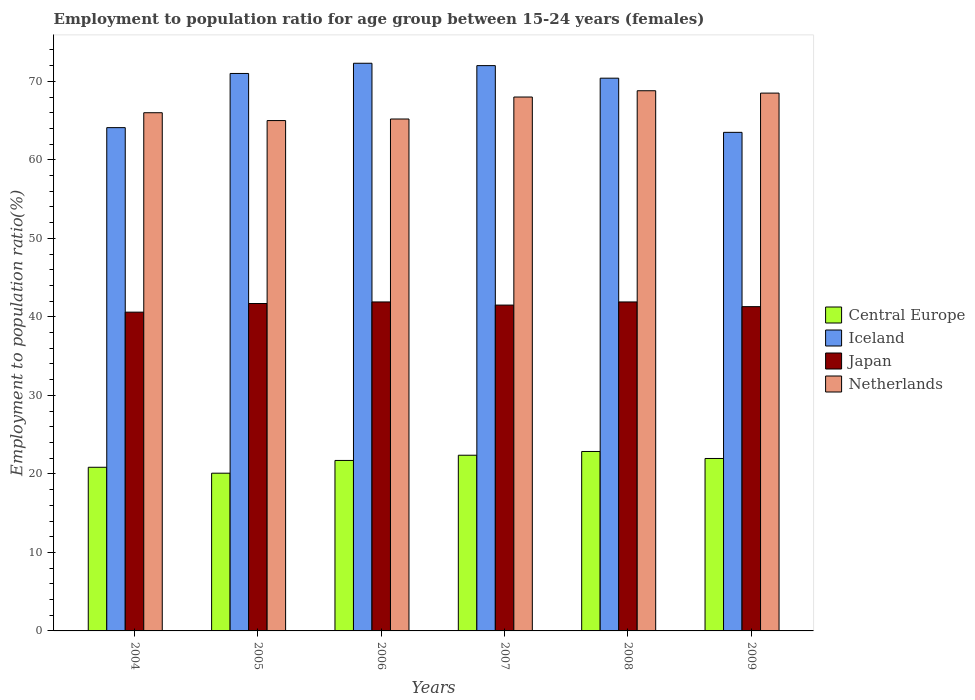How many bars are there on the 3rd tick from the right?
Your answer should be compact. 4. What is the label of the 6th group of bars from the left?
Your answer should be very brief. 2009. What is the employment to population ratio in Japan in 2008?
Offer a terse response. 41.9. Across all years, what is the maximum employment to population ratio in Iceland?
Ensure brevity in your answer.  72.3. Across all years, what is the minimum employment to population ratio in Japan?
Make the answer very short. 40.6. In which year was the employment to population ratio in Central Europe minimum?
Your response must be concise. 2005. What is the total employment to population ratio in Iceland in the graph?
Your answer should be very brief. 413.3. What is the difference between the employment to population ratio in Netherlands in 2007 and the employment to population ratio in Iceland in 2006?
Your answer should be very brief. -4.3. What is the average employment to population ratio in Japan per year?
Your response must be concise. 41.48. In the year 2009, what is the difference between the employment to population ratio in Japan and employment to population ratio in Iceland?
Your response must be concise. -22.2. In how many years, is the employment to population ratio in Iceland greater than 52 %?
Provide a short and direct response. 6. What is the ratio of the employment to population ratio in Iceland in 2006 to that in 2008?
Offer a very short reply. 1.03. Is the difference between the employment to population ratio in Japan in 2004 and 2009 greater than the difference between the employment to population ratio in Iceland in 2004 and 2009?
Offer a very short reply. No. What is the difference between the highest and the second highest employment to population ratio in Netherlands?
Your answer should be compact. 0.3. What is the difference between the highest and the lowest employment to population ratio in Netherlands?
Keep it short and to the point. 3.8. Is the sum of the employment to population ratio in Central Europe in 2007 and 2009 greater than the maximum employment to population ratio in Iceland across all years?
Provide a short and direct response. No. What does the 4th bar from the left in 2006 represents?
Make the answer very short. Netherlands. What does the 4th bar from the right in 2007 represents?
Make the answer very short. Central Europe. How many bars are there?
Make the answer very short. 24. Are all the bars in the graph horizontal?
Make the answer very short. No. How many years are there in the graph?
Keep it short and to the point. 6. What is the difference between two consecutive major ticks on the Y-axis?
Make the answer very short. 10. Are the values on the major ticks of Y-axis written in scientific E-notation?
Give a very brief answer. No. Does the graph contain any zero values?
Offer a very short reply. No. Does the graph contain grids?
Offer a terse response. No. Where does the legend appear in the graph?
Your answer should be compact. Center right. How many legend labels are there?
Offer a very short reply. 4. What is the title of the graph?
Your answer should be compact. Employment to population ratio for age group between 15-24 years (females). What is the label or title of the X-axis?
Give a very brief answer. Years. What is the label or title of the Y-axis?
Your answer should be compact. Employment to population ratio(%). What is the Employment to population ratio(%) of Central Europe in 2004?
Your answer should be very brief. 20.84. What is the Employment to population ratio(%) in Iceland in 2004?
Provide a succinct answer. 64.1. What is the Employment to population ratio(%) of Japan in 2004?
Your answer should be very brief. 40.6. What is the Employment to population ratio(%) of Central Europe in 2005?
Offer a terse response. 20.09. What is the Employment to population ratio(%) in Iceland in 2005?
Offer a very short reply. 71. What is the Employment to population ratio(%) in Japan in 2005?
Provide a succinct answer. 41.7. What is the Employment to population ratio(%) of Central Europe in 2006?
Give a very brief answer. 21.71. What is the Employment to population ratio(%) in Iceland in 2006?
Give a very brief answer. 72.3. What is the Employment to population ratio(%) in Japan in 2006?
Your answer should be very brief. 41.9. What is the Employment to population ratio(%) of Netherlands in 2006?
Offer a very short reply. 65.2. What is the Employment to population ratio(%) of Central Europe in 2007?
Provide a succinct answer. 22.38. What is the Employment to population ratio(%) of Japan in 2007?
Make the answer very short. 41.5. What is the Employment to population ratio(%) of Netherlands in 2007?
Ensure brevity in your answer.  68. What is the Employment to population ratio(%) in Central Europe in 2008?
Offer a terse response. 22.86. What is the Employment to population ratio(%) in Iceland in 2008?
Your answer should be very brief. 70.4. What is the Employment to population ratio(%) in Japan in 2008?
Provide a succinct answer. 41.9. What is the Employment to population ratio(%) of Netherlands in 2008?
Your answer should be compact. 68.8. What is the Employment to population ratio(%) of Central Europe in 2009?
Offer a terse response. 21.96. What is the Employment to population ratio(%) in Iceland in 2009?
Keep it short and to the point. 63.5. What is the Employment to population ratio(%) of Japan in 2009?
Ensure brevity in your answer.  41.3. What is the Employment to population ratio(%) in Netherlands in 2009?
Provide a short and direct response. 68.5. Across all years, what is the maximum Employment to population ratio(%) in Central Europe?
Your response must be concise. 22.86. Across all years, what is the maximum Employment to population ratio(%) in Iceland?
Your answer should be compact. 72.3. Across all years, what is the maximum Employment to population ratio(%) of Japan?
Your response must be concise. 41.9. Across all years, what is the maximum Employment to population ratio(%) of Netherlands?
Your response must be concise. 68.8. Across all years, what is the minimum Employment to population ratio(%) of Central Europe?
Give a very brief answer. 20.09. Across all years, what is the minimum Employment to population ratio(%) in Iceland?
Ensure brevity in your answer.  63.5. Across all years, what is the minimum Employment to population ratio(%) of Japan?
Your response must be concise. 40.6. What is the total Employment to population ratio(%) in Central Europe in the graph?
Offer a very short reply. 129.84. What is the total Employment to population ratio(%) of Iceland in the graph?
Provide a succinct answer. 413.3. What is the total Employment to population ratio(%) in Japan in the graph?
Ensure brevity in your answer.  248.9. What is the total Employment to population ratio(%) of Netherlands in the graph?
Your answer should be very brief. 401.5. What is the difference between the Employment to population ratio(%) in Central Europe in 2004 and that in 2005?
Keep it short and to the point. 0.76. What is the difference between the Employment to population ratio(%) of Netherlands in 2004 and that in 2005?
Provide a succinct answer. 1. What is the difference between the Employment to population ratio(%) of Central Europe in 2004 and that in 2006?
Ensure brevity in your answer.  -0.87. What is the difference between the Employment to population ratio(%) of Iceland in 2004 and that in 2006?
Ensure brevity in your answer.  -8.2. What is the difference between the Employment to population ratio(%) in Japan in 2004 and that in 2006?
Offer a very short reply. -1.3. What is the difference between the Employment to population ratio(%) of Central Europe in 2004 and that in 2007?
Ensure brevity in your answer.  -1.53. What is the difference between the Employment to population ratio(%) of Japan in 2004 and that in 2007?
Keep it short and to the point. -0.9. What is the difference between the Employment to population ratio(%) in Netherlands in 2004 and that in 2007?
Offer a terse response. -2. What is the difference between the Employment to population ratio(%) of Central Europe in 2004 and that in 2008?
Your response must be concise. -2.01. What is the difference between the Employment to population ratio(%) in Central Europe in 2004 and that in 2009?
Your answer should be very brief. -1.12. What is the difference between the Employment to population ratio(%) in Iceland in 2004 and that in 2009?
Provide a succinct answer. 0.6. What is the difference between the Employment to population ratio(%) in Japan in 2004 and that in 2009?
Offer a very short reply. -0.7. What is the difference between the Employment to population ratio(%) in Central Europe in 2005 and that in 2006?
Make the answer very short. -1.62. What is the difference between the Employment to population ratio(%) in Iceland in 2005 and that in 2006?
Your answer should be compact. -1.3. What is the difference between the Employment to population ratio(%) of Japan in 2005 and that in 2006?
Make the answer very short. -0.2. What is the difference between the Employment to population ratio(%) of Netherlands in 2005 and that in 2006?
Your response must be concise. -0.2. What is the difference between the Employment to population ratio(%) of Central Europe in 2005 and that in 2007?
Your response must be concise. -2.29. What is the difference between the Employment to population ratio(%) in Iceland in 2005 and that in 2007?
Provide a succinct answer. -1. What is the difference between the Employment to population ratio(%) of Japan in 2005 and that in 2007?
Keep it short and to the point. 0.2. What is the difference between the Employment to population ratio(%) in Central Europe in 2005 and that in 2008?
Offer a terse response. -2.77. What is the difference between the Employment to population ratio(%) of Iceland in 2005 and that in 2008?
Keep it short and to the point. 0.6. What is the difference between the Employment to population ratio(%) of Central Europe in 2005 and that in 2009?
Your answer should be very brief. -1.87. What is the difference between the Employment to population ratio(%) in Iceland in 2005 and that in 2009?
Provide a short and direct response. 7.5. What is the difference between the Employment to population ratio(%) in Japan in 2005 and that in 2009?
Your answer should be compact. 0.4. What is the difference between the Employment to population ratio(%) of Central Europe in 2006 and that in 2007?
Provide a short and direct response. -0.66. What is the difference between the Employment to population ratio(%) in Central Europe in 2006 and that in 2008?
Offer a very short reply. -1.14. What is the difference between the Employment to population ratio(%) in Netherlands in 2006 and that in 2008?
Give a very brief answer. -3.6. What is the difference between the Employment to population ratio(%) of Central Europe in 2006 and that in 2009?
Make the answer very short. -0.25. What is the difference between the Employment to population ratio(%) of Iceland in 2006 and that in 2009?
Give a very brief answer. 8.8. What is the difference between the Employment to population ratio(%) of Japan in 2006 and that in 2009?
Provide a succinct answer. 0.6. What is the difference between the Employment to population ratio(%) in Central Europe in 2007 and that in 2008?
Provide a short and direct response. -0.48. What is the difference between the Employment to population ratio(%) in Iceland in 2007 and that in 2008?
Ensure brevity in your answer.  1.6. What is the difference between the Employment to population ratio(%) of Japan in 2007 and that in 2008?
Your answer should be compact. -0.4. What is the difference between the Employment to population ratio(%) of Netherlands in 2007 and that in 2008?
Keep it short and to the point. -0.8. What is the difference between the Employment to population ratio(%) in Central Europe in 2007 and that in 2009?
Your response must be concise. 0.41. What is the difference between the Employment to population ratio(%) in Iceland in 2007 and that in 2009?
Ensure brevity in your answer.  8.5. What is the difference between the Employment to population ratio(%) of Japan in 2007 and that in 2009?
Provide a succinct answer. 0.2. What is the difference between the Employment to population ratio(%) in Netherlands in 2007 and that in 2009?
Provide a succinct answer. -0.5. What is the difference between the Employment to population ratio(%) of Central Europe in 2008 and that in 2009?
Give a very brief answer. 0.89. What is the difference between the Employment to population ratio(%) in Iceland in 2008 and that in 2009?
Offer a very short reply. 6.9. What is the difference between the Employment to population ratio(%) in Japan in 2008 and that in 2009?
Provide a succinct answer. 0.6. What is the difference between the Employment to population ratio(%) in Central Europe in 2004 and the Employment to population ratio(%) in Iceland in 2005?
Provide a succinct answer. -50.16. What is the difference between the Employment to population ratio(%) in Central Europe in 2004 and the Employment to population ratio(%) in Japan in 2005?
Make the answer very short. -20.86. What is the difference between the Employment to population ratio(%) of Central Europe in 2004 and the Employment to population ratio(%) of Netherlands in 2005?
Provide a succinct answer. -44.16. What is the difference between the Employment to population ratio(%) in Iceland in 2004 and the Employment to population ratio(%) in Japan in 2005?
Make the answer very short. 22.4. What is the difference between the Employment to population ratio(%) of Japan in 2004 and the Employment to population ratio(%) of Netherlands in 2005?
Give a very brief answer. -24.4. What is the difference between the Employment to population ratio(%) in Central Europe in 2004 and the Employment to population ratio(%) in Iceland in 2006?
Offer a terse response. -51.46. What is the difference between the Employment to population ratio(%) in Central Europe in 2004 and the Employment to population ratio(%) in Japan in 2006?
Ensure brevity in your answer.  -21.06. What is the difference between the Employment to population ratio(%) in Central Europe in 2004 and the Employment to population ratio(%) in Netherlands in 2006?
Your answer should be very brief. -44.36. What is the difference between the Employment to population ratio(%) of Iceland in 2004 and the Employment to population ratio(%) of Japan in 2006?
Make the answer very short. 22.2. What is the difference between the Employment to population ratio(%) of Iceland in 2004 and the Employment to population ratio(%) of Netherlands in 2006?
Give a very brief answer. -1.1. What is the difference between the Employment to population ratio(%) in Japan in 2004 and the Employment to population ratio(%) in Netherlands in 2006?
Offer a terse response. -24.6. What is the difference between the Employment to population ratio(%) of Central Europe in 2004 and the Employment to population ratio(%) of Iceland in 2007?
Ensure brevity in your answer.  -51.16. What is the difference between the Employment to population ratio(%) of Central Europe in 2004 and the Employment to population ratio(%) of Japan in 2007?
Provide a succinct answer. -20.66. What is the difference between the Employment to population ratio(%) of Central Europe in 2004 and the Employment to population ratio(%) of Netherlands in 2007?
Offer a terse response. -47.16. What is the difference between the Employment to population ratio(%) of Iceland in 2004 and the Employment to population ratio(%) of Japan in 2007?
Make the answer very short. 22.6. What is the difference between the Employment to population ratio(%) of Japan in 2004 and the Employment to population ratio(%) of Netherlands in 2007?
Ensure brevity in your answer.  -27.4. What is the difference between the Employment to population ratio(%) of Central Europe in 2004 and the Employment to population ratio(%) of Iceland in 2008?
Provide a short and direct response. -49.56. What is the difference between the Employment to population ratio(%) in Central Europe in 2004 and the Employment to population ratio(%) in Japan in 2008?
Ensure brevity in your answer.  -21.06. What is the difference between the Employment to population ratio(%) in Central Europe in 2004 and the Employment to population ratio(%) in Netherlands in 2008?
Keep it short and to the point. -47.96. What is the difference between the Employment to population ratio(%) in Iceland in 2004 and the Employment to population ratio(%) in Netherlands in 2008?
Your answer should be compact. -4.7. What is the difference between the Employment to population ratio(%) in Japan in 2004 and the Employment to population ratio(%) in Netherlands in 2008?
Offer a terse response. -28.2. What is the difference between the Employment to population ratio(%) of Central Europe in 2004 and the Employment to population ratio(%) of Iceland in 2009?
Provide a succinct answer. -42.66. What is the difference between the Employment to population ratio(%) of Central Europe in 2004 and the Employment to population ratio(%) of Japan in 2009?
Make the answer very short. -20.46. What is the difference between the Employment to population ratio(%) of Central Europe in 2004 and the Employment to population ratio(%) of Netherlands in 2009?
Give a very brief answer. -47.66. What is the difference between the Employment to population ratio(%) in Iceland in 2004 and the Employment to population ratio(%) in Japan in 2009?
Provide a short and direct response. 22.8. What is the difference between the Employment to population ratio(%) in Iceland in 2004 and the Employment to population ratio(%) in Netherlands in 2009?
Offer a very short reply. -4.4. What is the difference between the Employment to population ratio(%) in Japan in 2004 and the Employment to population ratio(%) in Netherlands in 2009?
Give a very brief answer. -27.9. What is the difference between the Employment to population ratio(%) in Central Europe in 2005 and the Employment to population ratio(%) in Iceland in 2006?
Your answer should be compact. -52.21. What is the difference between the Employment to population ratio(%) of Central Europe in 2005 and the Employment to population ratio(%) of Japan in 2006?
Your answer should be compact. -21.81. What is the difference between the Employment to population ratio(%) of Central Europe in 2005 and the Employment to population ratio(%) of Netherlands in 2006?
Your answer should be very brief. -45.11. What is the difference between the Employment to population ratio(%) in Iceland in 2005 and the Employment to population ratio(%) in Japan in 2006?
Your answer should be compact. 29.1. What is the difference between the Employment to population ratio(%) in Japan in 2005 and the Employment to population ratio(%) in Netherlands in 2006?
Offer a terse response. -23.5. What is the difference between the Employment to population ratio(%) of Central Europe in 2005 and the Employment to population ratio(%) of Iceland in 2007?
Give a very brief answer. -51.91. What is the difference between the Employment to population ratio(%) of Central Europe in 2005 and the Employment to population ratio(%) of Japan in 2007?
Your answer should be compact. -21.41. What is the difference between the Employment to population ratio(%) in Central Europe in 2005 and the Employment to population ratio(%) in Netherlands in 2007?
Your answer should be very brief. -47.91. What is the difference between the Employment to population ratio(%) of Iceland in 2005 and the Employment to population ratio(%) of Japan in 2007?
Your response must be concise. 29.5. What is the difference between the Employment to population ratio(%) in Japan in 2005 and the Employment to population ratio(%) in Netherlands in 2007?
Your response must be concise. -26.3. What is the difference between the Employment to population ratio(%) in Central Europe in 2005 and the Employment to population ratio(%) in Iceland in 2008?
Your answer should be compact. -50.31. What is the difference between the Employment to population ratio(%) of Central Europe in 2005 and the Employment to population ratio(%) of Japan in 2008?
Offer a terse response. -21.81. What is the difference between the Employment to population ratio(%) in Central Europe in 2005 and the Employment to population ratio(%) in Netherlands in 2008?
Ensure brevity in your answer.  -48.71. What is the difference between the Employment to population ratio(%) in Iceland in 2005 and the Employment to population ratio(%) in Japan in 2008?
Make the answer very short. 29.1. What is the difference between the Employment to population ratio(%) in Iceland in 2005 and the Employment to population ratio(%) in Netherlands in 2008?
Provide a short and direct response. 2.2. What is the difference between the Employment to population ratio(%) in Japan in 2005 and the Employment to population ratio(%) in Netherlands in 2008?
Your response must be concise. -27.1. What is the difference between the Employment to population ratio(%) of Central Europe in 2005 and the Employment to population ratio(%) of Iceland in 2009?
Provide a short and direct response. -43.41. What is the difference between the Employment to population ratio(%) in Central Europe in 2005 and the Employment to population ratio(%) in Japan in 2009?
Provide a succinct answer. -21.21. What is the difference between the Employment to population ratio(%) in Central Europe in 2005 and the Employment to population ratio(%) in Netherlands in 2009?
Your answer should be very brief. -48.41. What is the difference between the Employment to population ratio(%) in Iceland in 2005 and the Employment to population ratio(%) in Japan in 2009?
Make the answer very short. 29.7. What is the difference between the Employment to population ratio(%) of Iceland in 2005 and the Employment to population ratio(%) of Netherlands in 2009?
Make the answer very short. 2.5. What is the difference between the Employment to population ratio(%) of Japan in 2005 and the Employment to population ratio(%) of Netherlands in 2009?
Make the answer very short. -26.8. What is the difference between the Employment to population ratio(%) in Central Europe in 2006 and the Employment to population ratio(%) in Iceland in 2007?
Offer a terse response. -50.29. What is the difference between the Employment to population ratio(%) of Central Europe in 2006 and the Employment to population ratio(%) of Japan in 2007?
Your answer should be compact. -19.79. What is the difference between the Employment to population ratio(%) of Central Europe in 2006 and the Employment to population ratio(%) of Netherlands in 2007?
Give a very brief answer. -46.29. What is the difference between the Employment to population ratio(%) of Iceland in 2006 and the Employment to population ratio(%) of Japan in 2007?
Your answer should be very brief. 30.8. What is the difference between the Employment to population ratio(%) of Japan in 2006 and the Employment to population ratio(%) of Netherlands in 2007?
Offer a very short reply. -26.1. What is the difference between the Employment to population ratio(%) in Central Europe in 2006 and the Employment to population ratio(%) in Iceland in 2008?
Make the answer very short. -48.69. What is the difference between the Employment to population ratio(%) in Central Europe in 2006 and the Employment to population ratio(%) in Japan in 2008?
Keep it short and to the point. -20.19. What is the difference between the Employment to population ratio(%) in Central Europe in 2006 and the Employment to population ratio(%) in Netherlands in 2008?
Ensure brevity in your answer.  -47.09. What is the difference between the Employment to population ratio(%) in Iceland in 2006 and the Employment to population ratio(%) in Japan in 2008?
Your answer should be very brief. 30.4. What is the difference between the Employment to population ratio(%) in Iceland in 2006 and the Employment to population ratio(%) in Netherlands in 2008?
Offer a terse response. 3.5. What is the difference between the Employment to population ratio(%) in Japan in 2006 and the Employment to population ratio(%) in Netherlands in 2008?
Make the answer very short. -26.9. What is the difference between the Employment to population ratio(%) in Central Europe in 2006 and the Employment to population ratio(%) in Iceland in 2009?
Give a very brief answer. -41.79. What is the difference between the Employment to population ratio(%) of Central Europe in 2006 and the Employment to population ratio(%) of Japan in 2009?
Provide a succinct answer. -19.59. What is the difference between the Employment to population ratio(%) in Central Europe in 2006 and the Employment to population ratio(%) in Netherlands in 2009?
Give a very brief answer. -46.79. What is the difference between the Employment to population ratio(%) in Iceland in 2006 and the Employment to population ratio(%) in Japan in 2009?
Your answer should be very brief. 31. What is the difference between the Employment to population ratio(%) of Japan in 2006 and the Employment to population ratio(%) of Netherlands in 2009?
Ensure brevity in your answer.  -26.6. What is the difference between the Employment to population ratio(%) of Central Europe in 2007 and the Employment to population ratio(%) of Iceland in 2008?
Offer a very short reply. -48.02. What is the difference between the Employment to population ratio(%) in Central Europe in 2007 and the Employment to population ratio(%) in Japan in 2008?
Offer a terse response. -19.52. What is the difference between the Employment to population ratio(%) of Central Europe in 2007 and the Employment to population ratio(%) of Netherlands in 2008?
Offer a terse response. -46.42. What is the difference between the Employment to population ratio(%) in Iceland in 2007 and the Employment to population ratio(%) in Japan in 2008?
Offer a terse response. 30.1. What is the difference between the Employment to population ratio(%) of Japan in 2007 and the Employment to population ratio(%) of Netherlands in 2008?
Your answer should be compact. -27.3. What is the difference between the Employment to population ratio(%) of Central Europe in 2007 and the Employment to population ratio(%) of Iceland in 2009?
Make the answer very short. -41.12. What is the difference between the Employment to population ratio(%) of Central Europe in 2007 and the Employment to population ratio(%) of Japan in 2009?
Provide a succinct answer. -18.92. What is the difference between the Employment to population ratio(%) in Central Europe in 2007 and the Employment to population ratio(%) in Netherlands in 2009?
Your answer should be compact. -46.12. What is the difference between the Employment to population ratio(%) of Iceland in 2007 and the Employment to population ratio(%) of Japan in 2009?
Keep it short and to the point. 30.7. What is the difference between the Employment to population ratio(%) in Iceland in 2007 and the Employment to population ratio(%) in Netherlands in 2009?
Provide a short and direct response. 3.5. What is the difference between the Employment to population ratio(%) in Central Europe in 2008 and the Employment to population ratio(%) in Iceland in 2009?
Give a very brief answer. -40.64. What is the difference between the Employment to population ratio(%) of Central Europe in 2008 and the Employment to population ratio(%) of Japan in 2009?
Keep it short and to the point. -18.44. What is the difference between the Employment to population ratio(%) of Central Europe in 2008 and the Employment to population ratio(%) of Netherlands in 2009?
Your answer should be compact. -45.64. What is the difference between the Employment to population ratio(%) in Iceland in 2008 and the Employment to population ratio(%) in Japan in 2009?
Give a very brief answer. 29.1. What is the difference between the Employment to population ratio(%) in Iceland in 2008 and the Employment to population ratio(%) in Netherlands in 2009?
Keep it short and to the point. 1.9. What is the difference between the Employment to population ratio(%) in Japan in 2008 and the Employment to population ratio(%) in Netherlands in 2009?
Provide a short and direct response. -26.6. What is the average Employment to population ratio(%) in Central Europe per year?
Make the answer very short. 21.64. What is the average Employment to population ratio(%) of Iceland per year?
Your answer should be compact. 68.88. What is the average Employment to population ratio(%) of Japan per year?
Ensure brevity in your answer.  41.48. What is the average Employment to population ratio(%) of Netherlands per year?
Ensure brevity in your answer.  66.92. In the year 2004, what is the difference between the Employment to population ratio(%) in Central Europe and Employment to population ratio(%) in Iceland?
Your answer should be compact. -43.26. In the year 2004, what is the difference between the Employment to population ratio(%) in Central Europe and Employment to population ratio(%) in Japan?
Make the answer very short. -19.76. In the year 2004, what is the difference between the Employment to population ratio(%) of Central Europe and Employment to population ratio(%) of Netherlands?
Provide a succinct answer. -45.16. In the year 2004, what is the difference between the Employment to population ratio(%) of Iceland and Employment to population ratio(%) of Japan?
Give a very brief answer. 23.5. In the year 2004, what is the difference between the Employment to population ratio(%) of Iceland and Employment to population ratio(%) of Netherlands?
Your answer should be compact. -1.9. In the year 2004, what is the difference between the Employment to population ratio(%) in Japan and Employment to population ratio(%) in Netherlands?
Provide a short and direct response. -25.4. In the year 2005, what is the difference between the Employment to population ratio(%) in Central Europe and Employment to population ratio(%) in Iceland?
Offer a very short reply. -50.91. In the year 2005, what is the difference between the Employment to population ratio(%) of Central Europe and Employment to population ratio(%) of Japan?
Provide a short and direct response. -21.61. In the year 2005, what is the difference between the Employment to population ratio(%) in Central Europe and Employment to population ratio(%) in Netherlands?
Provide a short and direct response. -44.91. In the year 2005, what is the difference between the Employment to population ratio(%) in Iceland and Employment to population ratio(%) in Japan?
Your answer should be very brief. 29.3. In the year 2005, what is the difference between the Employment to population ratio(%) of Japan and Employment to population ratio(%) of Netherlands?
Keep it short and to the point. -23.3. In the year 2006, what is the difference between the Employment to population ratio(%) in Central Europe and Employment to population ratio(%) in Iceland?
Offer a terse response. -50.59. In the year 2006, what is the difference between the Employment to population ratio(%) of Central Europe and Employment to population ratio(%) of Japan?
Offer a terse response. -20.19. In the year 2006, what is the difference between the Employment to population ratio(%) of Central Europe and Employment to population ratio(%) of Netherlands?
Provide a succinct answer. -43.49. In the year 2006, what is the difference between the Employment to population ratio(%) of Iceland and Employment to population ratio(%) of Japan?
Your response must be concise. 30.4. In the year 2006, what is the difference between the Employment to population ratio(%) of Japan and Employment to population ratio(%) of Netherlands?
Make the answer very short. -23.3. In the year 2007, what is the difference between the Employment to population ratio(%) of Central Europe and Employment to population ratio(%) of Iceland?
Ensure brevity in your answer.  -49.62. In the year 2007, what is the difference between the Employment to population ratio(%) in Central Europe and Employment to population ratio(%) in Japan?
Make the answer very short. -19.12. In the year 2007, what is the difference between the Employment to population ratio(%) of Central Europe and Employment to population ratio(%) of Netherlands?
Provide a short and direct response. -45.62. In the year 2007, what is the difference between the Employment to population ratio(%) in Iceland and Employment to population ratio(%) in Japan?
Provide a short and direct response. 30.5. In the year 2007, what is the difference between the Employment to population ratio(%) in Iceland and Employment to population ratio(%) in Netherlands?
Offer a very short reply. 4. In the year 2007, what is the difference between the Employment to population ratio(%) in Japan and Employment to population ratio(%) in Netherlands?
Your response must be concise. -26.5. In the year 2008, what is the difference between the Employment to population ratio(%) in Central Europe and Employment to population ratio(%) in Iceland?
Offer a very short reply. -47.54. In the year 2008, what is the difference between the Employment to population ratio(%) of Central Europe and Employment to population ratio(%) of Japan?
Provide a succinct answer. -19.04. In the year 2008, what is the difference between the Employment to population ratio(%) in Central Europe and Employment to population ratio(%) in Netherlands?
Offer a very short reply. -45.94. In the year 2008, what is the difference between the Employment to population ratio(%) of Iceland and Employment to population ratio(%) of Japan?
Make the answer very short. 28.5. In the year 2008, what is the difference between the Employment to population ratio(%) of Japan and Employment to population ratio(%) of Netherlands?
Your answer should be very brief. -26.9. In the year 2009, what is the difference between the Employment to population ratio(%) of Central Europe and Employment to population ratio(%) of Iceland?
Provide a succinct answer. -41.54. In the year 2009, what is the difference between the Employment to population ratio(%) in Central Europe and Employment to population ratio(%) in Japan?
Provide a short and direct response. -19.34. In the year 2009, what is the difference between the Employment to population ratio(%) in Central Europe and Employment to population ratio(%) in Netherlands?
Your answer should be compact. -46.54. In the year 2009, what is the difference between the Employment to population ratio(%) of Iceland and Employment to population ratio(%) of Japan?
Your answer should be very brief. 22.2. In the year 2009, what is the difference between the Employment to population ratio(%) of Japan and Employment to population ratio(%) of Netherlands?
Your answer should be compact. -27.2. What is the ratio of the Employment to population ratio(%) of Central Europe in 2004 to that in 2005?
Make the answer very short. 1.04. What is the ratio of the Employment to population ratio(%) of Iceland in 2004 to that in 2005?
Your answer should be very brief. 0.9. What is the ratio of the Employment to population ratio(%) of Japan in 2004 to that in 2005?
Your response must be concise. 0.97. What is the ratio of the Employment to population ratio(%) of Netherlands in 2004 to that in 2005?
Your response must be concise. 1.02. What is the ratio of the Employment to population ratio(%) in Iceland in 2004 to that in 2006?
Ensure brevity in your answer.  0.89. What is the ratio of the Employment to population ratio(%) of Japan in 2004 to that in 2006?
Offer a very short reply. 0.97. What is the ratio of the Employment to population ratio(%) in Netherlands in 2004 to that in 2006?
Your answer should be very brief. 1.01. What is the ratio of the Employment to population ratio(%) in Central Europe in 2004 to that in 2007?
Your answer should be compact. 0.93. What is the ratio of the Employment to population ratio(%) in Iceland in 2004 to that in 2007?
Your answer should be compact. 0.89. What is the ratio of the Employment to population ratio(%) of Japan in 2004 to that in 2007?
Give a very brief answer. 0.98. What is the ratio of the Employment to population ratio(%) in Netherlands in 2004 to that in 2007?
Your answer should be very brief. 0.97. What is the ratio of the Employment to population ratio(%) of Central Europe in 2004 to that in 2008?
Make the answer very short. 0.91. What is the ratio of the Employment to population ratio(%) of Iceland in 2004 to that in 2008?
Your response must be concise. 0.91. What is the ratio of the Employment to population ratio(%) of Netherlands in 2004 to that in 2008?
Provide a short and direct response. 0.96. What is the ratio of the Employment to population ratio(%) of Central Europe in 2004 to that in 2009?
Offer a very short reply. 0.95. What is the ratio of the Employment to population ratio(%) of Iceland in 2004 to that in 2009?
Offer a very short reply. 1.01. What is the ratio of the Employment to population ratio(%) of Japan in 2004 to that in 2009?
Ensure brevity in your answer.  0.98. What is the ratio of the Employment to population ratio(%) of Netherlands in 2004 to that in 2009?
Your response must be concise. 0.96. What is the ratio of the Employment to population ratio(%) in Central Europe in 2005 to that in 2006?
Offer a terse response. 0.93. What is the ratio of the Employment to population ratio(%) of Central Europe in 2005 to that in 2007?
Provide a short and direct response. 0.9. What is the ratio of the Employment to population ratio(%) in Iceland in 2005 to that in 2007?
Provide a succinct answer. 0.99. What is the ratio of the Employment to population ratio(%) in Japan in 2005 to that in 2007?
Ensure brevity in your answer.  1. What is the ratio of the Employment to population ratio(%) in Netherlands in 2005 to that in 2007?
Your response must be concise. 0.96. What is the ratio of the Employment to population ratio(%) in Central Europe in 2005 to that in 2008?
Your answer should be compact. 0.88. What is the ratio of the Employment to population ratio(%) in Iceland in 2005 to that in 2008?
Ensure brevity in your answer.  1.01. What is the ratio of the Employment to population ratio(%) in Japan in 2005 to that in 2008?
Make the answer very short. 1. What is the ratio of the Employment to population ratio(%) of Netherlands in 2005 to that in 2008?
Your answer should be compact. 0.94. What is the ratio of the Employment to population ratio(%) of Central Europe in 2005 to that in 2009?
Your response must be concise. 0.91. What is the ratio of the Employment to population ratio(%) of Iceland in 2005 to that in 2009?
Your answer should be compact. 1.12. What is the ratio of the Employment to population ratio(%) of Japan in 2005 to that in 2009?
Provide a succinct answer. 1.01. What is the ratio of the Employment to population ratio(%) in Netherlands in 2005 to that in 2009?
Make the answer very short. 0.95. What is the ratio of the Employment to population ratio(%) in Central Europe in 2006 to that in 2007?
Give a very brief answer. 0.97. What is the ratio of the Employment to population ratio(%) of Japan in 2006 to that in 2007?
Make the answer very short. 1.01. What is the ratio of the Employment to population ratio(%) in Netherlands in 2006 to that in 2007?
Keep it short and to the point. 0.96. What is the ratio of the Employment to population ratio(%) in Central Europe in 2006 to that in 2008?
Your answer should be very brief. 0.95. What is the ratio of the Employment to population ratio(%) in Iceland in 2006 to that in 2008?
Ensure brevity in your answer.  1.03. What is the ratio of the Employment to population ratio(%) in Netherlands in 2006 to that in 2008?
Offer a very short reply. 0.95. What is the ratio of the Employment to population ratio(%) in Central Europe in 2006 to that in 2009?
Your answer should be compact. 0.99. What is the ratio of the Employment to population ratio(%) in Iceland in 2006 to that in 2009?
Ensure brevity in your answer.  1.14. What is the ratio of the Employment to population ratio(%) of Japan in 2006 to that in 2009?
Offer a very short reply. 1.01. What is the ratio of the Employment to population ratio(%) of Netherlands in 2006 to that in 2009?
Your answer should be compact. 0.95. What is the ratio of the Employment to population ratio(%) of Central Europe in 2007 to that in 2008?
Your answer should be very brief. 0.98. What is the ratio of the Employment to population ratio(%) in Iceland in 2007 to that in 2008?
Offer a terse response. 1.02. What is the ratio of the Employment to population ratio(%) of Japan in 2007 to that in 2008?
Provide a succinct answer. 0.99. What is the ratio of the Employment to population ratio(%) of Netherlands in 2007 to that in 2008?
Provide a short and direct response. 0.99. What is the ratio of the Employment to population ratio(%) in Central Europe in 2007 to that in 2009?
Make the answer very short. 1.02. What is the ratio of the Employment to population ratio(%) of Iceland in 2007 to that in 2009?
Provide a succinct answer. 1.13. What is the ratio of the Employment to population ratio(%) in Japan in 2007 to that in 2009?
Provide a short and direct response. 1. What is the ratio of the Employment to population ratio(%) in Central Europe in 2008 to that in 2009?
Keep it short and to the point. 1.04. What is the ratio of the Employment to population ratio(%) in Iceland in 2008 to that in 2009?
Offer a very short reply. 1.11. What is the ratio of the Employment to population ratio(%) of Japan in 2008 to that in 2009?
Offer a very short reply. 1.01. What is the difference between the highest and the second highest Employment to population ratio(%) of Central Europe?
Offer a very short reply. 0.48. What is the difference between the highest and the second highest Employment to population ratio(%) in Japan?
Your answer should be compact. 0. What is the difference between the highest and the second highest Employment to population ratio(%) in Netherlands?
Offer a very short reply. 0.3. What is the difference between the highest and the lowest Employment to population ratio(%) in Central Europe?
Provide a short and direct response. 2.77. What is the difference between the highest and the lowest Employment to population ratio(%) of Iceland?
Make the answer very short. 8.8. 